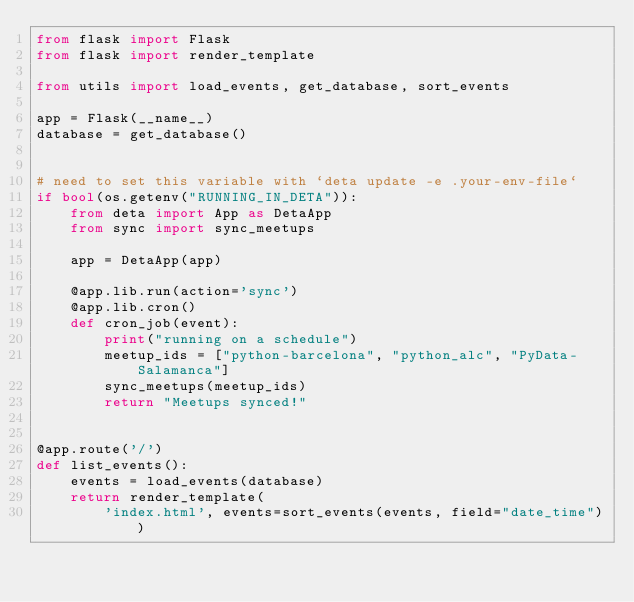<code> <loc_0><loc_0><loc_500><loc_500><_Python_>from flask import Flask
from flask import render_template

from utils import load_events, get_database, sort_events

app = Flask(__name__)
database = get_database()


# need to set this variable with `deta update -e .your-env-file`
if bool(os.getenv("RUNNING_IN_DETA")):
    from deta import App as DetaApp
    from sync import sync_meetups

    app = DetaApp(app)

    @app.lib.run(action='sync')
    @app.lib.cron()
    def cron_job(event):
        print("running on a schedule")
        meetup_ids = ["python-barcelona", "python_alc", "PyData-Salamanca"]
        sync_meetups(meetup_ids)
        return "Meetups synced!"


@app.route('/')
def list_events():
    events = load_events(database)
    return render_template(
        'index.html', events=sort_events(events, field="date_time"))
</code> 